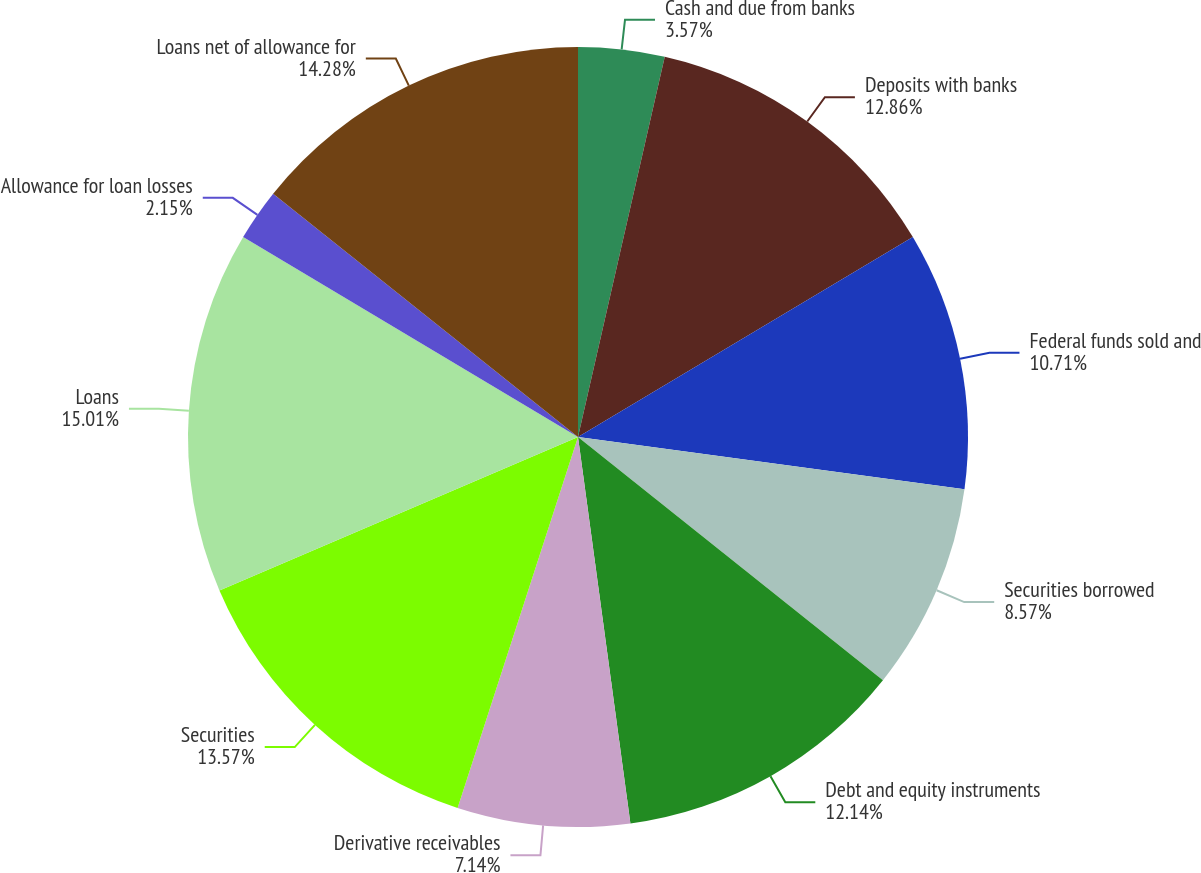<chart> <loc_0><loc_0><loc_500><loc_500><pie_chart><fcel>Cash and due from banks<fcel>Deposits with banks<fcel>Federal funds sold and<fcel>Securities borrowed<fcel>Debt and equity instruments<fcel>Derivative receivables<fcel>Securities<fcel>Loans<fcel>Allowance for loan losses<fcel>Loans net of allowance for<nl><fcel>3.57%<fcel>12.86%<fcel>10.71%<fcel>8.57%<fcel>12.14%<fcel>7.14%<fcel>13.57%<fcel>15.0%<fcel>2.15%<fcel>14.28%<nl></chart> 